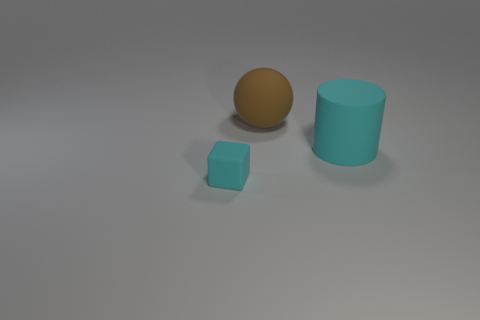Add 3 large blue cylinders. How many objects exist? 6 Subtract all cylinders. How many objects are left? 2 Add 3 cyan things. How many cyan things are left? 5 Add 3 cyan cylinders. How many cyan cylinders exist? 4 Subtract 0 blue blocks. How many objects are left? 3 Subtract all green objects. Subtract all brown balls. How many objects are left? 2 